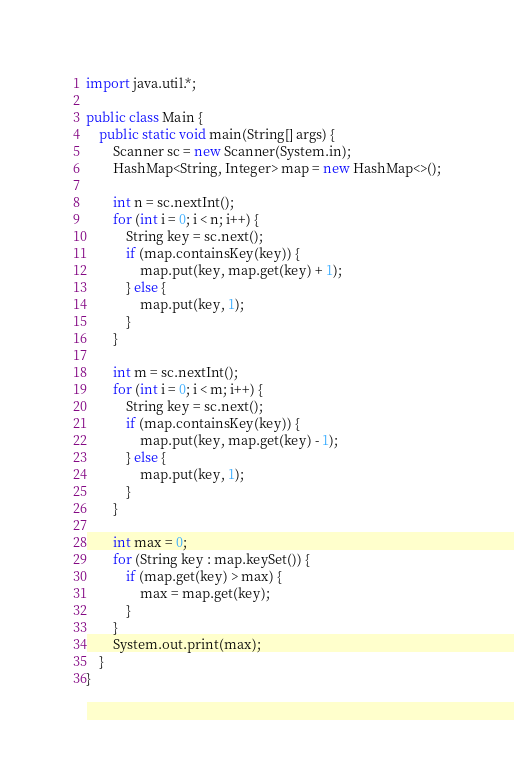<code> <loc_0><loc_0><loc_500><loc_500><_Java_>import java.util.*;

public class Main {
    public static void main(String[] args) {
        Scanner sc = new Scanner(System.in);
        HashMap<String, Integer> map = new HashMap<>();

        int n = sc.nextInt();
        for (int i = 0; i < n; i++) {
            String key = sc.next();
            if (map.containsKey(key)) {
                map.put(key, map.get(key) + 1);
            } else {
                map.put(key, 1);
            }
        }

        int m = sc.nextInt();
        for (int i = 0; i < m; i++) {
            String key = sc.next();
            if (map.containsKey(key)) {
                map.put(key, map.get(key) - 1);
            } else {
                map.put(key, 1);
            }
        }

        int max = 0;
        for (String key : map.keySet()) {
            if (map.get(key) > max) {
                max = map.get(key);
            }
        }
        System.out.print(max);
    }
}</code> 